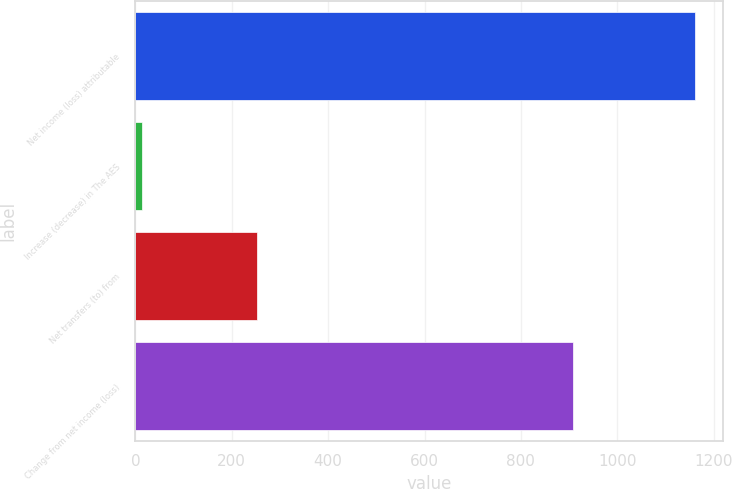Convert chart to OTSL. <chart><loc_0><loc_0><loc_500><loc_500><bar_chart><fcel>Net income (loss) attributable<fcel>Increase (decrease) in The AES<fcel>Net transfers (to) from<fcel>Change from net income (loss)<nl><fcel>1161<fcel>13<fcel>253<fcel>908<nl></chart> 